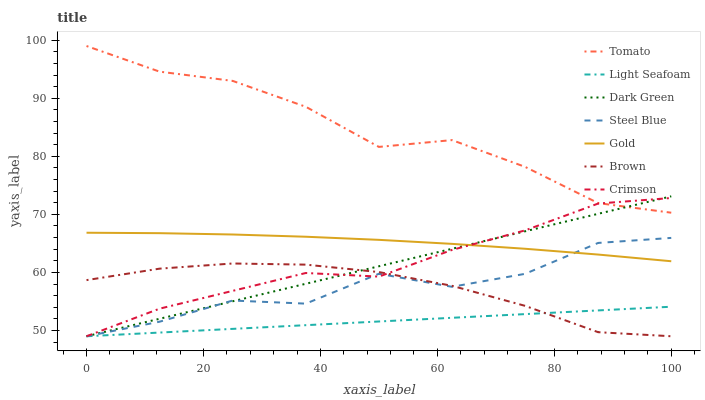Does Brown have the minimum area under the curve?
Answer yes or no. No. Does Brown have the maximum area under the curve?
Answer yes or no. No. Is Brown the smoothest?
Answer yes or no. No. Is Brown the roughest?
Answer yes or no. No. Does Gold have the lowest value?
Answer yes or no. No. Does Brown have the highest value?
Answer yes or no. No. Is Brown less than Gold?
Answer yes or no. Yes. Is Gold greater than Brown?
Answer yes or no. Yes. Does Brown intersect Gold?
Answer yes or no. No. 